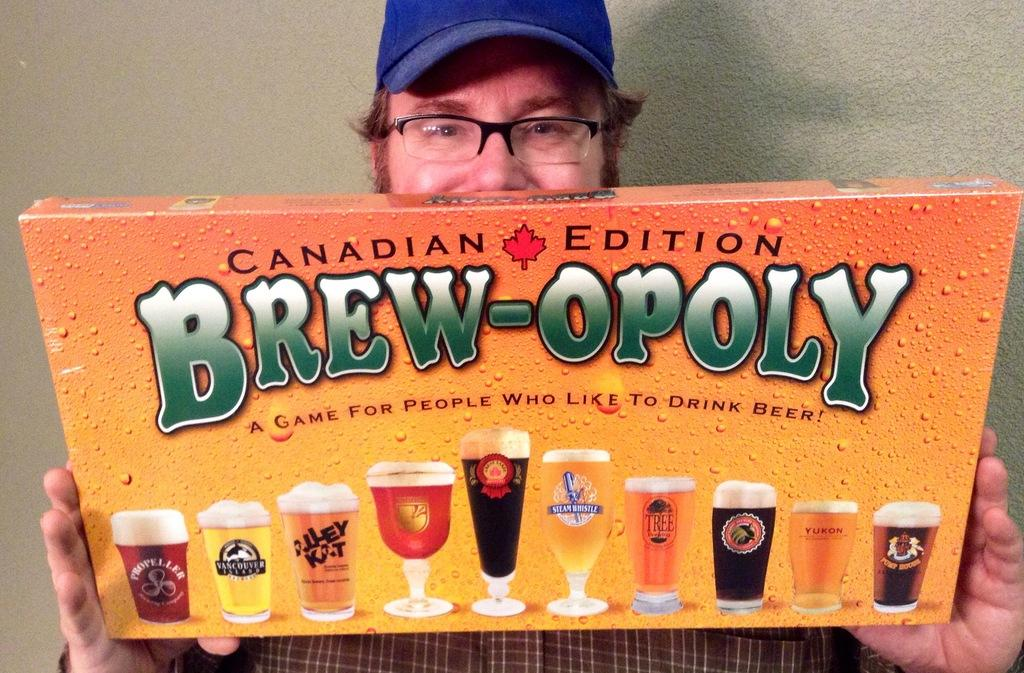<image>
Write a terse but informative summary of the picture. A man holds and shows off a board game called Canadian Edition Brew-opoly. 